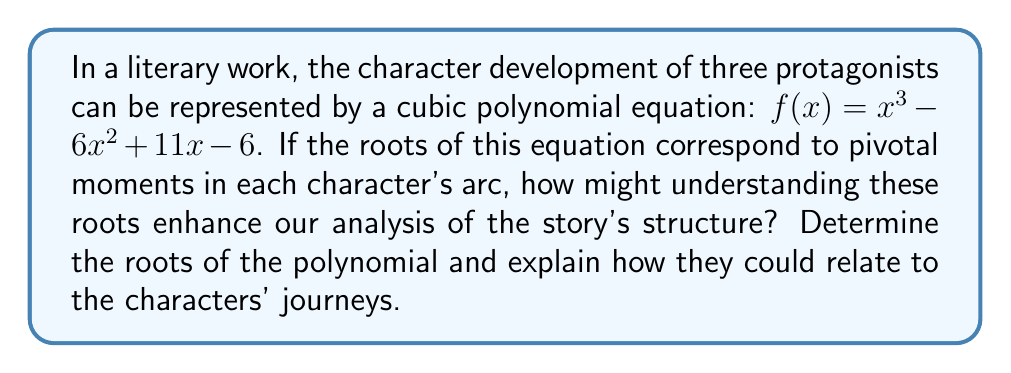Provide a solution to this math problem. To understand how the roots of the polynomial equation relate to character development, we first need to find these roots. The roots of a polynomial equation are the values of x that make the equation equal to zero.

For the cubic equation $f(x) = x^3 - 6x^2 + 11x - 6$, we can find the roots by factoring:

1) First, let's guess one factor. We can see that $f(1) = 1 - 6 + 11 - 6 = 0$, so $(x-1)$ is a factor.

2) We can then divide the polynomial by $(x-1)$ to get the other factor:

   $x^3 - 6x^2 + 11x - 6 = (x-1)(x^2 - 5x + 6)$

3) The quadratic factor $x^2 - 5x + 6$ can be further factored:

   $x^2 - 5x + 6 = (x-2)(x-3)$

4) Therefore, the fully factored polynomial is:

   $f(x) = (x-1)(x-2)(x-3)$

The roots of the polynomial are thus 1, 2, and 3.

In terms of character development, these roots could represent crucial moments or turning points in each protagonist's journey:

- The root x = 1 might represent the initial conflict or call to action that sets each character on their path.
- The root x = 2 could symbolize a midpoint crisis or significant challenge that forces character growth.
- The root x = 3 might indicate the climax or resolution of each character's arc.

Understanding these roots can enhance our analysis of the story's structure by providing a mathematical framework for the characters' developmental stages. It suggests a three-act structure, with each act culminating in a pivotal moment (represented by a root) that transforms the characters.

This polynomial perspective offers a unique way to visualize character growth, with the roots serving as anchors for key narrative events. It also implies a synchronicity in the characters' journeys, as they all experience significant changes at these common points, though the nature of these changes may differ for each character.
Answer: The roots of the polynomial $f(x) = x^3 - 6x^2 + 11x - 6$ are 1, 2, and 3. These roots can be interpreted as representing three pivotal moments in the characters' development, potentially corresponding to the initial conflict, a midpoint crisis, and the final resolution of their character arcs. 